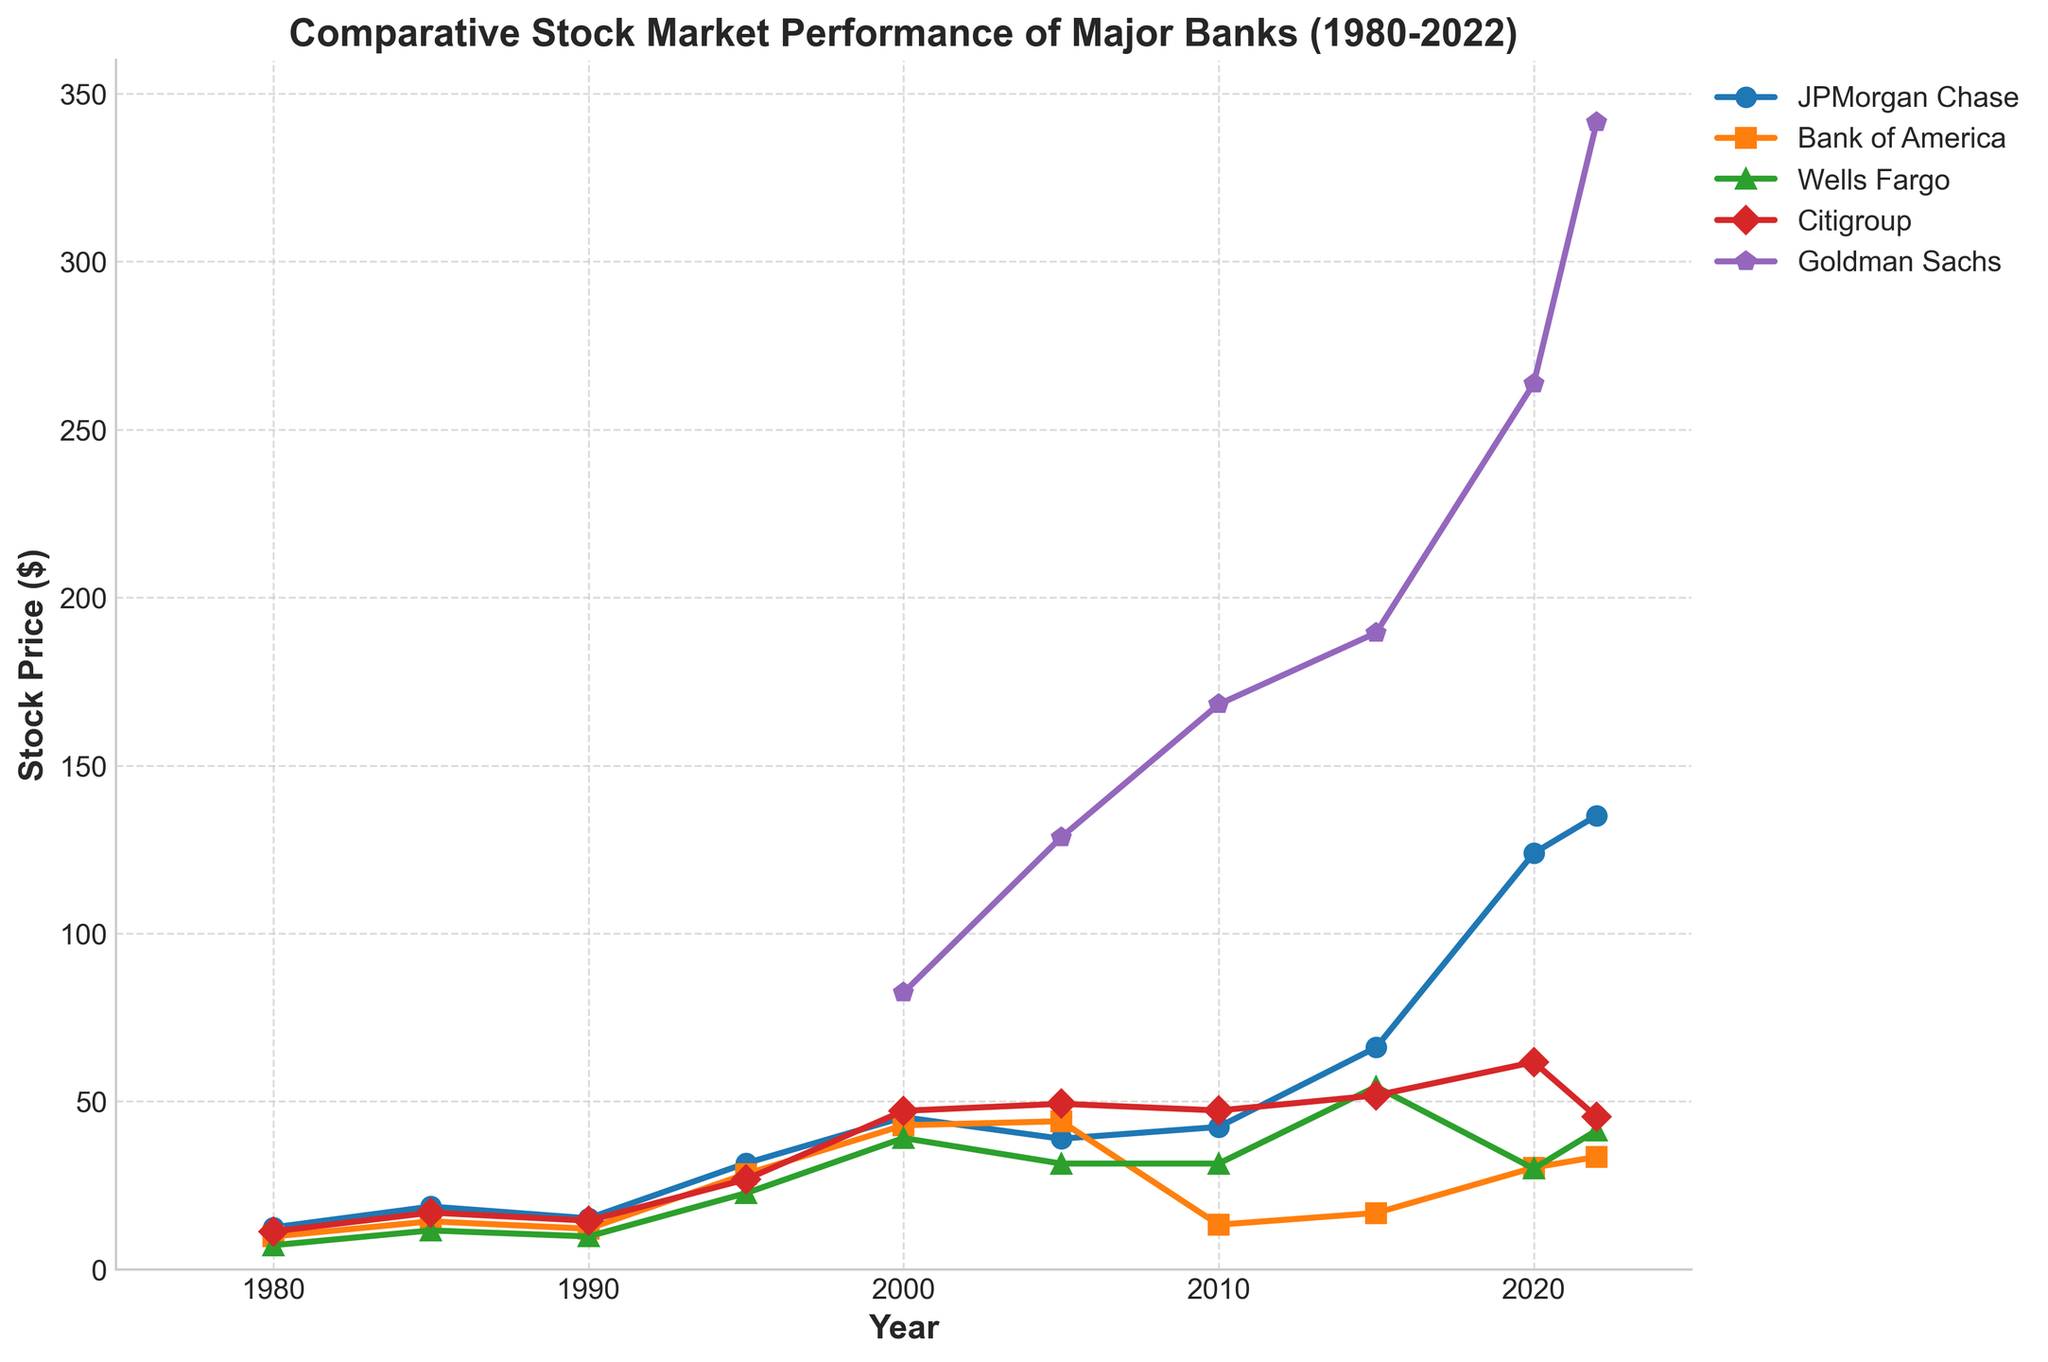Which bank shows the highest stock price in 2022? Observe the highest point on the graph for the year 2022. Goldman Sachs has the highest stock price in 2022.
Answer: Goldman Sachs Which two banks had a similar stock price trend from 1980 to 2022? Look for banks with similar slopes and patterns over the years. Citigroup and JPMorgan Chase show a similar trend from 1980 to 2022.
Answer: Citigroup and JPMorgan Chase How did the stock price of Wells Fargo change from 1995 to 2000? Check the change in Wells Fargo's stock price between 1995 and 2000. The stock price increased from 22.7 to 39.1.
Answer: Increased Which bank had the lowest stock price in 2010? Find the lowest point on the graph for the year 2010. Bank of America had the lowest stock price in 2010.
Answer: Bank of America What was the difference in stock price between Bank of America and Goldman Sachs in 2020? Identify the stock prices for both banks in 2020 and subtract Bank of America's from Goldman Sachs's. The difference is 263.7 - 30.3 = 233.4
Answer: 233.4 Which bank shows the most significant growth in stock price between 2000 and 2022? Analyze the difference in stock prices from 2000 to 2022 for each bank. Goldman Sachs shows the most significant growth (341.5 - 82.4 = 259.1).
Answer: Goldman Sachs What was the average stock price of JPMorgan Chase across all the years? Sum up JPMorgan Chase's stock prices and divide by the number of data points (8). The average is (12.5 + 18.7 + 15.2 + 31.6 + 45.3 + 38.9 + 42.4 + 66.1 + 123.9 + 135.1) / 10 = 53.97.
Answer: 53.97 How did Citigroup's stock price trend differ from Wells Fargo's between 2015 and 2022? Compare the patterns from 2015 to 2022 for both banks. Citigroup's stock price fell while Wells Fargo's stock price trended upward.
Answer: Citigroup fell, Wells Fargo rose Which bank saw a decline in stock price after 2000? Identify which bank's stock dropped after 2000. Bank of America experienced a decline post-2000.
Answer: Bank of America From 1980 to present, which bank had consistent upward growth with fewer fluctuations? Analyze for a bank with consistent increments and fewer dips. JPMorgan Chase displays consistent upward growth with fewer fluctuations.
Answer: JPMorgan Chase 